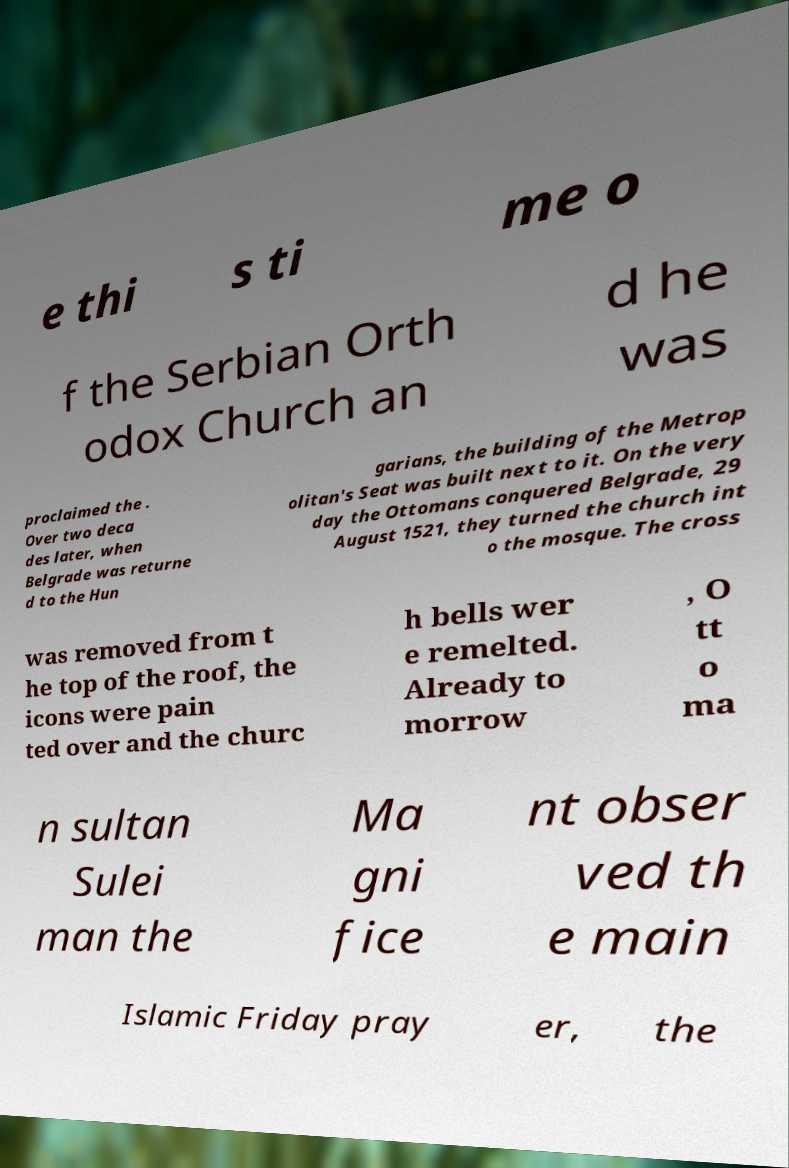Please read and relay the text visible in this image. What does it say? e thi s ti me o f the Serbian Orth odox Church an d he was proclaimed the . Over two deca des later, when Belgrade was returne d to the Hun garians, the building of the Metrop olitan's Seat was built next to it. On the very day the Ottomans conquered Belgrade, 29 August 1521, they turned the church int o the mosque. The cross was removed from t he top of the roof, the icons were pain ted over and the churc h bells wer e remelted. Already to morrow , O tt o ma n sultan Sulei man the Ma gni fice nt obser ved th e main Islamic Friday pray er, the 